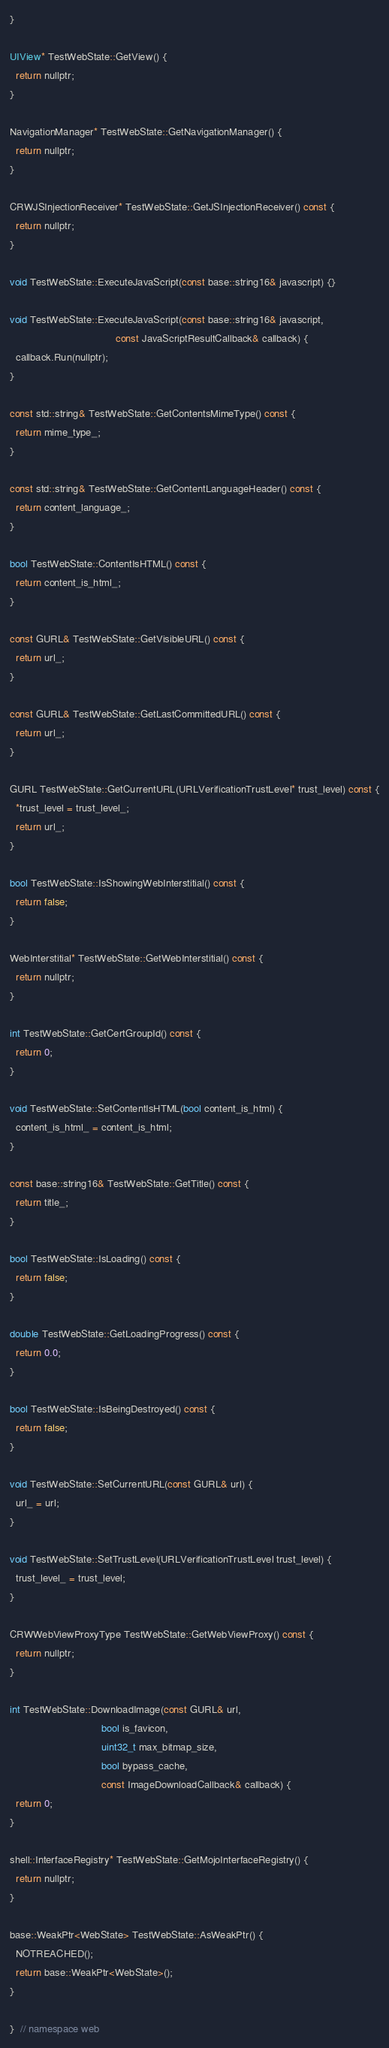<code> <loc_0><loc_0><loc_500><loc_500><_ObjectiveC_>}

UIView* TestWebState::GetView() {
  return nullptr;
}

NavigationManager* TestWebState::GetNavigationManager() {
  return nullptr;
}

CRWJSInjectionReceiver* TestWebState::GetJSInjectionReceiver() const {
  return nullptr;
}

void TestWebState::ExecuteJavaScript(const base::string16& javascript) {}

void TestWebState::ExecuteJavaScript(const base::string16& javascript,
                                     const JavaScriptResultCallback& callback) {
  callback.Run(nullptr);
}

const std::string& TestWebState::GetContentsMimeType() const {
  return mime_type_;
}

const std::string& TestWebState::GetContentLanguageHeader() const {
  return content_language_;
}

bool TestWebState::ContentIsHTML() const {
  return content_is_html_;
}

const GURL& TestWebState::GetVisibleURL() const {
  return url_;
}

const GURL& TestWebState::GetLastCommittedURL() const {
  return url_;
}

GURL TestWebState::GetCurrentURL(URLVerificationTrustLevel* trust_level) const {
  *trust_level = trust_level_;
  return url_;
}

bool TestWebState::IsShowingWebInterstitial() const {
  return false;
}

WebInterstitial* TestWebState::GetWebInterstitial() const {
  return nullptr;
}

int TestWebState::GetCertGroupId() const {
  return 0;
}

void TestWebState::SetContentIsHTML(bool content_is_html) {
  content_is_html_ = content_is_html;
}

const base::string16& TestWebState::GetTitle() const {
  return title_;
}

bool TestWebState::IsLoading() const {
  return false;
}

double TestWebState::GetLoadingProgress() const {
  return 0.0;
}

bool TestWebState::IsBeingDestroyed() const {
  return false;
}

void TestWebState::SetCurrentURL(const GURL& url) {
  url_ = url;
}

void TestWebState::SetTrustLevel(URLVerificationTrustLevel trust_level) {
  trust_level_ = trust_level;
}

CRWWebViewProxyType TestWebState::GetWebViewProxy() const {
  return nullptr;
}

int TestWebState::DownloadImage(const GURL& url,
                                bool is_favicon,
                                uint32_t max_bitmap_size,
                                bool bypass_cache,
                                const ImageDownloadCallback& callback) {
  return 0;
}

shell::InterfaceRegistry* TestWebState::GetMojoInterfaceRegistry() {
  return nullptr;
}

base::WeakPtr<WebState> TestWebState::AsWeakPtr() {
  NOTREACHED();
  return base::WeakPtr<WebState>();
}

}  // namespace web
</code> 